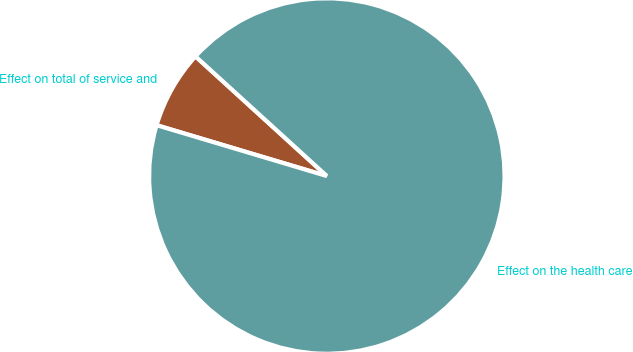<chart> <loc_0><loc_0><loc_500><loc_500><pie_chart><fcel>Effect on total of service and<fcel>Effect on the health care<nl><fcel>7.14%<fcel>92.86%<nl></chart> 